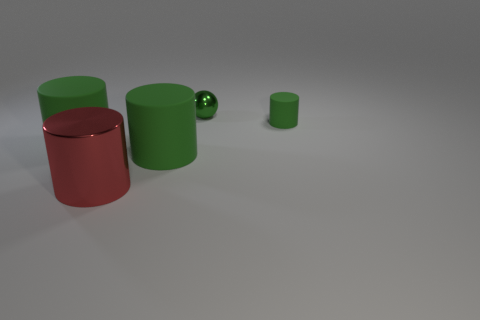Does the size of the objects relate to their distance from the viewer? Yes, there is a perspective at play in the image. The objects decrease in size from left to right, suggesting that the smaller green cylinder and the sphere are further away from the viewer when compared to the other cylinders. 